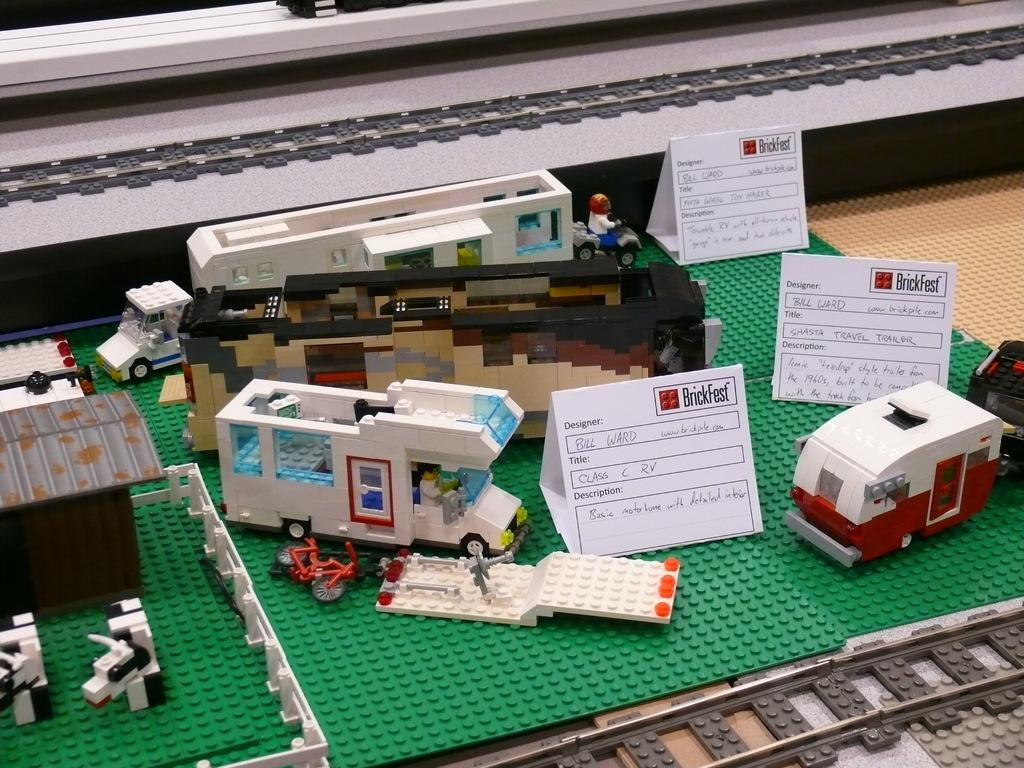What type of toys are present in the image? There are lego toys in the image. What are the lego toys placed on? There are lego boards in the image. What is on top of the lego boards? There are white boards on the lego boards. Where is the secretary sitting in the image? There is no secretary present in the image. What type of ant can be seen crawling on the lego toys? There are no ants present in the image. 